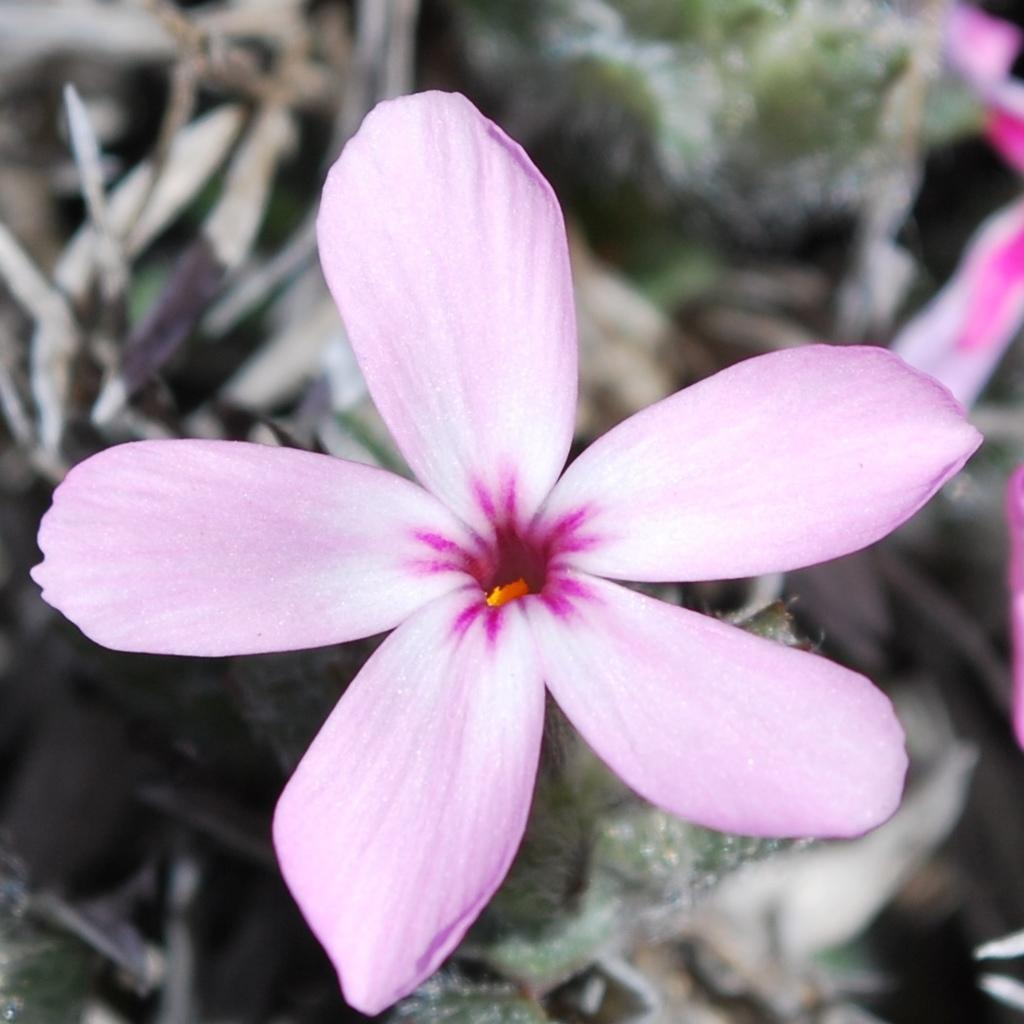What is the main subject of the image? There is a flower in the image. How many petals does the flower have? The flower has five petals. What else can be seen in the background of the image? There are leaves visible in the background of the image. Where are the petals located in the image? The petals are on the right side of the image. What type of nut is being used to cover the flower in the image? There is no nut present in the image, and the flower is not being covered by any object. 